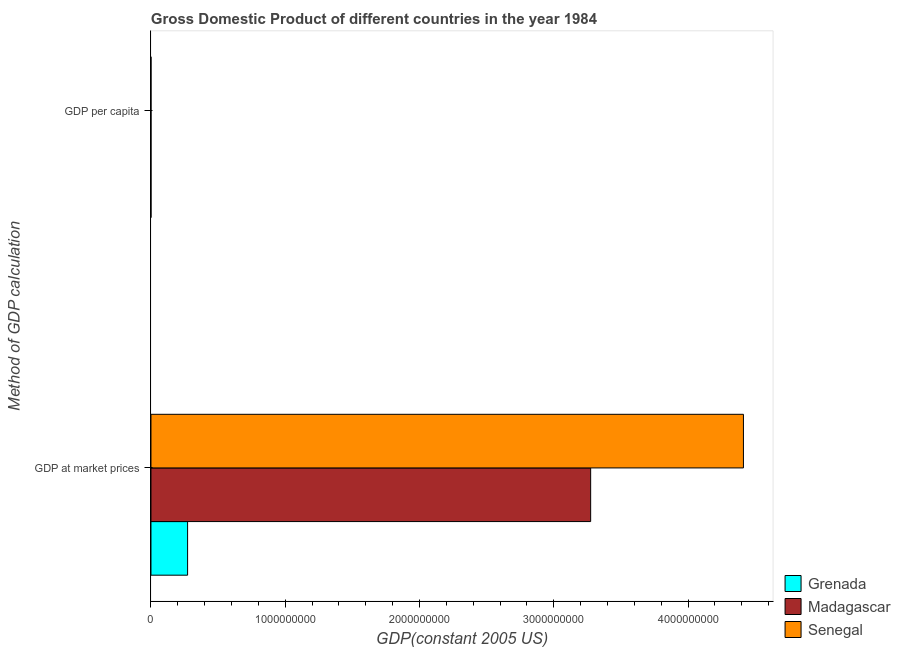How many different coloured bars are there?
Ensure brevity in your answer.  3. How many groups of bars are there?
Keep it short and to the point. 2. Are the number of bars per tick equal to the number of legend labels?
Your answer should be compact. Yes. How many bars are there on the 1st tick from the top?
Make the answer very short. 3. What is the label of the 2nd group of bars from the top?
Offer a terse response. GDP at market prices. What is the gdp at market prices in Madagascar?
Your response must be concise. 3.27e+09. Across all countries, what is the maximum gdp per capita?
Give a very brief answer. 2771.66. Across all countries, what is the minimum gdp at market prices?
Give a very brief answer. 2.73e+08. In which country was the gdp at market prices maximum?
Your response must be concise. Senegal. In which country was the gdp at market prices minimum?
Provide a succinct answer. Grenada. What is the total gdp at market prices in the graph?
Make the answer very short. 7.96e+09. What is the difference between the gdp per capita in Grenada and that in Senegal?
Provide a succinct answer. 2065.29. What is the difference between the gdp at market prices in Senegal and the gdp per capita in Madagascar?
Give a very brief answer. 4.41e+09. What is the average gdp at market prices per country?
Give a very brief answer. 2.65e+09. What is the difference between the gdp at market prices and gdp per capita in Senegal?
Make the answer very short. 4.41e+09. In how many countries, is the gdp at market prices greater than 400000000 US$?
Your answer should be very brief. 2. What is the ratio of the gdp per capita in Grenada to that in Senegal?
Offer a terse response. 3.92. Is the gdp per capita in Madagascar less than that in Senegal?
Your answer should be very brief. Yes. What does the 1st bar from the top in GDP at market prices represents?
Provide a succinct answer. Senegal. What does the 2nd bar from the bottom in GDP per capita represents?
Your answer should be very brief. Madagascar. What is the difference between two consecutive major ticks on the X-axis?
Your answer should be very brief. 1.00e+09. Does the graph contain any zero values?
Offer a terse response. No. How are the legend labels stacked?
Your answer should be very brief. Vertical. What is the title of the graph?
Your answer should be very brief. Gross Domestic Product of different countries in the year 1984. Does "Albania" appear as one of the legend labels in the graph?
Offer a very short reply. No. What is the label or title of the X-axis?
Your answer should be compact. GDP(constant 2005 US). What is the label or title of the Y-axis?
Your response must be concise. Method of GDP calculation. What is the GDP(constant 2005 US) of Grenada in GDP at market prices?
Provide a short and direct response. 2.73e+08. What is the GDP(constant 2005 US) of Madagascar in GDP at market prices?
Offer a very short reply. 3.27e+09. What is the GDP(constant 2005 US) in Senegal in GDP at market prices?
Provide a succinct answer. 4.41e+09. What is the GDP(constant 2005 US) in Grenada in GDP per capita?
Your answer should be compact. 2771.66. What is the GDP(constant 2005 US) in Madagascar in GDP per capita?
Give a very brief answer. 337.06. What is the GDP(constant 2005 US) in Senegal in GDP per capita?
Give a very brief answer. 706.37. Across all Method of GDP calculation, what is the maximum GDP(constant 2005 US) in Grenada?
Your answer should be very brief. 2.73e+08. Across all Method of GDP calculation, what is the maximum GDP(constant 2005 US) of Madagascar?
Make the answer very short. 3.27e+09. Across all Method of GDP calculation, what is the maximum GDP(constant 2005 US) in Senegal?
Ensure brevity in your answer.  4.41e+09. Across all Method of GDP calculation, what is the minimum GDP(constant 2005 US) of Grenada?
Your answer should be compact. 2771.66. Across all Method of GDP calculation, what is the minimum GDP(constant 2005 US) of Madagascar?
Keep it short and to the point. 337.06. Across all Method of GDP calculation, what is the minimum GDP(constant 2005 US) in Senegal?
Offer a terse response. 706.37. What is the total GDP(constant 2005 US) in Grenada in the graph?
Keep it short and to the point. 2.73e+08. What is the total GDP(constant 2005 US) in Madagascar in the graph?
Make the answer very short. 3.27e+09. What is the total GDP(constant 2005 US) of Senegal in the graph?
Give a very brief answer. 4.41e+09. What is the difference between the GDP(constant 2005 US) of Grenada in GDP at market prices and that in GDP per capita?
Offer a terse response. 2.73e+08. What is the difference between the GDP(constant 2005 US) of Madagascar in GDP at market prices and that in GDP per capita?
Give a very brief answer. 3.27e+09. What is the difference between the GDP(constant 2005 US) of Senegal in GDP at market prices and that in GDP per capita?
Make the answer very short. 4.41e+09. What is the difference between the GDP(constant 2005 US) in Grenada in GDP at market prices and the GDP(constant 2005 US) in Madagascar in GDP per capita?
Your answer should be very brief. 2.73e+08. What is the difference between the GDP(constant 2005 US) of Grenada in GDP at market prices and the GDP(constant 2005 US) of Senegal in GDP per capita?
Offer a very short reply. 2.73e+08. What is the difference between the GDP(constant 2005 US) of Madagascar in GDP at market prices and the GDP(constant 2005 US) of Senegal in GDP per capita?
Provide a short and direct response. 3.27e+09. What is the average GDP(constant 2005 US) of Grenada per Method of GDP calculation?
Offer a terse response. 1.36e+08. What is the average GDP(constant 2005 US) in Madagascar per Method of GDP calculation?
Keep it short and to the point. 1.64e+09. What is the average GDP(constant 2005 US) of Senegal per Method of GDP calculation?
Offer a very short reply. 2.21e+09. What is the difference between the GDP(constant 2005 US) of Grenada and GDP(constant 2005 US) of Madagascar in GDP at market prices?
Make the answer very short. -3.00e+09. What is the difference between the GDP(constant 2005 US) in Grenada and GDP(constant 2005 US) in Senegal in GDP at market prices?
Your answer should be compact. -4.14e+09. What is the difference between the GDP(constant 2005 US) in Madagascar and GDP(constant 2005 US) in Senegal in GDP at market prices?
Your answer should be compact. -1.14e+09. What is the difference between the GDP(constant 2005 US) of Grenada and GDP(constant 2005 US) of Madagascar in GDP per capita?
Make the answer very short. 2434.6. What is the difference between the GDP(constant 2005 US) of Grenada and GDP(constant 2005 US) of Senegal in GDP per capita?
Give a very brief answer. 2065.29. What is the difference between the GDP(constant 2005 US) of Madagascar and GDP(constant 2005 US) of Senegal in GDP per capita?
Provide a short and direct response. -369.31. What is the ratio of the GDP(constant 2005 US) in Grenada in GDP at market prices to that in GDP per capita?
Offer a terse response. 9.84e+04. What is the ratio of the GDP(constant 2005 US) in Madagascar in GDP at market prices to that in GDP per capita?
Ensure brevity in your answer.  9.71e+06. What is the ratio of the GDP(constant 2005 US) of Senegal in GDP at market prices to that in GDP per capita?
Offer a terse response. 6.25e+06. What is the difference between the highest and the second highest GDP(constant 2005 US) of Grenada?
Ensure brevity in your answer.  2.73e+08. What is the difference between the highest and the second highest GDP(constant 2005 US) in Madagascar?
Keep it short and to the point. 3.27e+09. What is the difference between the highest and the second highest GDP(constant 2005 US) of Senegal?
Your answer should be compact. 4.41e+09. What is the difference between the highest and the lowest GDP(constant 2005 US) of Grenada?
Your answer should be compact. 2.73e+08. What is the difference between the highest and the lowest GDP(constant 2005 US) of Madagascar?
Give a very brief answer. 3.27e+09. What is the difference between the highest and the lowest GDP(constant 2005 US) in Senegal?
Provide a short and direct response. 4.41e+09. 